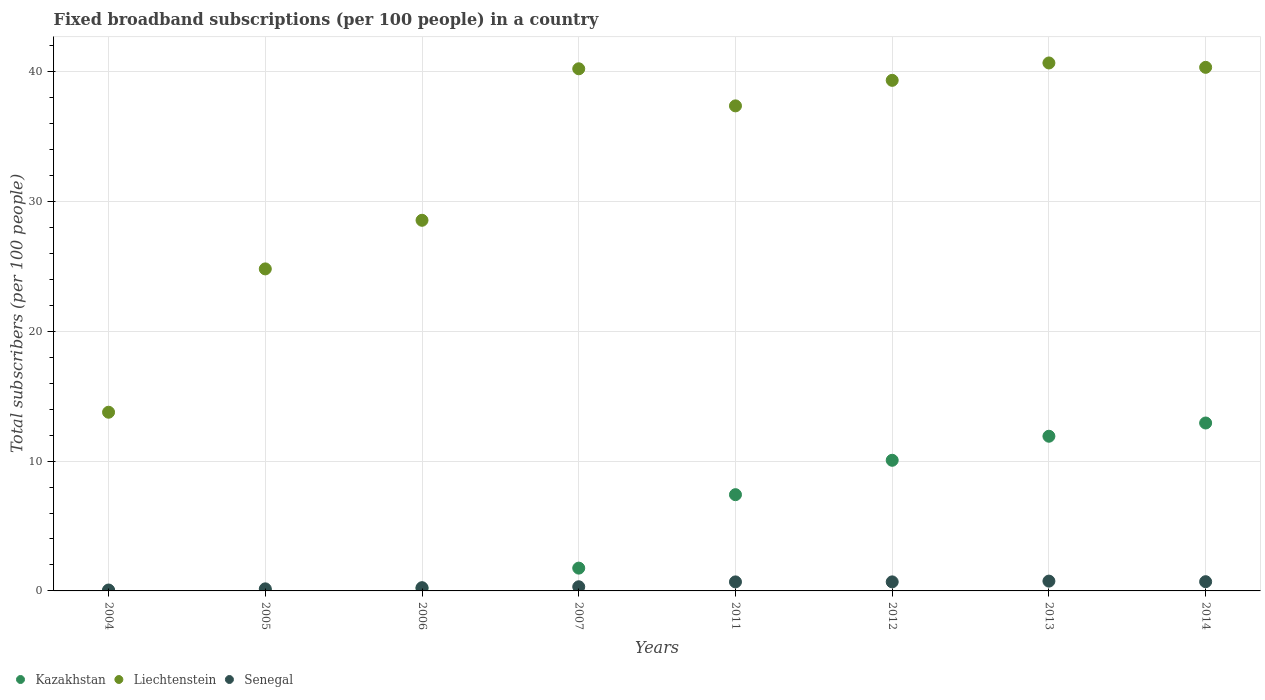How many different coloured dotlines are there?
Provide a short and direct response. 3. What is the number of broadband subscriptions in Senegal in 2013?
Provide a succinct answer. 0.76. Across all years, what is the maximum number of broadband subscriptions in Kazakhstan?
Give a very brief answer. 12.93. Across all years, what is the minimum number of broadband subscriptions in Kazakhstan?
Keep it short and to the point. 0.01. What is the total number of broadband subscriptions in Kazakhstan in the graph?
Offer a very short reply. 44.31. What is the difference between the number of broadband subscriptions in Kazakhstan in 2007 and that in 2012?
Your response must be concise. -8.31. What is the difference between the number of broadband subscriptions in Liechtenstein in 2013 and the number of broadband subscriptions in Kazakhstan in 2005?
Your answer should be compact. 40.65. What is the average number of broadband subscriptions in Liechtenstein per year?
Keep it short and to the point. 33.13. In the year 2004, what is the difference between the number of broadband subscriptions in Senegal and number of broadband subscriptions in Liechtenstein?
Your response must be concise. -13.69. What is the ratio of the number of broadband subscriptions in Liechtenstein in 2005 to that in 2011?
Offer a very short reply. 0.66. Is the number of broadband subscriptions in Senegal in 2007 less than that in 2012?
Offer a very short reply. Yes. What is the difference between the highest and the second highest number of broadband subscriptions in Kazakhstan?
Keep it short and to the point. 1.02. What is the difference between the highest and the lowest number of broadband subscriptions in Kazakhstan?
Offer a very short reply. 12.92. Is it the case that in every year, the sum of the number of broadband subscriptions in Liechtenstein and number of broadband subscriptions in Kazakhstan  is greater than the number of broadband subscriptions in Senegal?
Give a very brief answer. Yes. Is the number of broadband subscriptions in Kazakhstan strictly greater than the number of broadband subscriptions in Senegal over the years?
Offer a terse response. No. Is the number of broadband subscriptions in Senegal strictly less than the number of broadband subscriptions in Liechtenstein over the years?
Offer a very short reply. Yes. How many years are there in the graph?
Provide a succinct answer. 8. What is the difference between two consecutive major ticks on the Y-axis?
Offer a very short reply. 10. Does the graph contain grids?
Provide a succinct answer. Yes. What is the title of the graph?
Keep it short and to the point. Fixed broadband subscriptions (per 100 people) in a country. What is the label or title of the Y-axis?
Make the answer very short. Total subscribers (per 100 people). What is the Total subscribers (per 100 people) in Kazakhstan in 2004?
Make the answer very short. 0.01. What is the Total subscribers (per 100 people) in Liechtenstein in 2004?
Give a very brief answer. 13.76. What is the Total subscribers (per 100 people) in Senegal in 2004?
Your answer should be compact. 0.07. What is the Total subscribers (per 100 people) in Kazakhstan in 2005?
Offer a terse response. 0.02. What is the Total subscribers (per 100 people) of Liechtenstein in 2005?
Offer a very short reply. 24.8. What is the Total subscribers (per 100 people) of Senegal in 2005?
Offer a very short reply. 0.16. What is the Total subscribers (per 100 people) in Kazakhstan in 2006?
Your response must be concise. 0.2. What is the Total subscribers (per 100 people) in Liechtenstein in 2006?
Offer a very short reply. 28.55. What is the Total subscribers (per 100 people) in Senegal in 2006?
Make the answer very short. 0.25. What is the Total subscribers (per 100 people) of Kazakhstan in 2007?
Your answer should be compact. 1.76. What is the Total subscribers (per 100 people) in Liechtenstein in 2007?
Offer a terse response. 40.22. What is the Total subscribers (per 100 people) in Senegal in 2007?
Offer a terse response. 0.32. What is the Total subscribers (per 100 people) in Kazakhstan in 2011?
Your answer should be compact. 7.41. What is the Total subscribers (per 100 people) of Liechtenstein in 2011?
Give a very brief answer. 37.36. What is the Total subscribers (per 100 people) in Senegal in 2011?
Give a very brief answer. 0.7. What is the Total subscribers (per 100 people) of Kazakhstan in 2012?
Ensure brevity in your answer.  10.06. What is the Total subscribers (per 100 people) in Liechtenstein in 2012?
Your answer should be compact. 39.33. What is the Total subscribers (per 100 people) in Senegal in 2012?
Offer a very short reply. 0.7. What is the Total subscribers (per 100 people) of Kazakhstan in 2013?
Your answer should be compact. 11.91. What is the Total subscribers (per 100 people) in Liechtenstein in 2013?
Make the answer very short. 40.67. What is the Total subscribers (per 100 people) of Senegal in 2013?
Offer a very short reply. 0.76. What is the Total subscribers (per 100 people) in Kazakhstan in 2014?
Make the answer very short. 12.93. What is the Total subscribers (per 100 people) of Liechtenstein in 2014?
Offer a very short reply. 40.33. What is the Total subscribers (per 100 people) in Senegal in 2014?
Your response must be concise. 0.71. Across all years, what is the maximum Total subscribers (per 100 people) in Kazakhstan?
Your answer should be very brief. 12.93. Across all years, what is the maximum Total subscribers (per 100 people) of Liechtenstein?
Offer a terse response. 40.67. Across all years, what is the maximum Total subscribers (per 100 people) in Senegal?
Offer a very short reply. 0.76. Across all years, what is the minimum Total subscribers (per 100 people) of Kazakhstan?
Offer a very short reply. 0.01. Across all years, what is the minimum Total subscribers (per 100 people) in Liechtenstein?
Make the answer very short. 13.76. Across all years, what is the minimum Total subscribers (per 100 people) in Senegal?
Your answer should be very brief. 0.07. What is the total Total subscribers (per 100 people) of Kazakhstan in the graph?
Offer a terse response. 44.31. What is the total Total subscribers (per 100 people) in Liechtenstein in the graph?
Make the answer very short. 265.02. What is the total Total subscribers (per 100 people) of Senegal in the graph?
Make the answer very short. 3.66. What is the difference between the Total subscribers (per 100 people) of Kazakhstan in 2004 and that in 2005?
Make the answer very short. -0.01. What is the difference between the Total subscribers (per 100 people) of Liechtenstein in 2004 and that in 2005?
Give a very brief answer. -11.04. What is the difference between the Total subscribers (per 100 people) in Senegal in 2004 and that in 2005?
Provide a succinct answer. -0.09. What is the difference between the Total subscribers (per 100 people) in Kazakhstan in 2004 and that in 2006?
Give a very brief answer. -0.19. What is the difference between the Total subscribers (per 100 people) of Liechtenstein in 2004 and that in 2006?
Your answer should be very brief. -14.78. What is the difference between the Total subscribers (per 100 people) in Senegal in 2004 and that in 2006?
Your answer should be very brief. -0.18. What is the difference between the Total subscribers (per 100 people) in Kazakhstan in 2004 and that in 2007?
Offer a terse response. -1.74. What is the difference between the Total subscribers (per 100 people) in Liechtenstein in 2004 and that in 2007?
Provide a short and direct response. -26.45. What is the difference between the Total subscribers (per 100 people) in Senegal in 2004 and that in 2007?
Provide a short and direct response. -0.25. What is the difference between the Total subscribers (per 100 people) in Kazakhstan in 2004 and that in 2011?
Your answer should be compact. -7.4. What is the difference between the Total subscribers (per 100 people) in Liechtenstein in 2004 and that in 2011?
Ensure brevity in your answer.  -23.6. What is the difference between the Total subscribers (per 100 people) of Senegal in 2004 and that in 2011?
Your answer should be compact. -0.63. What is the difference between the Total subscribers (per 100 people) of Kazakhstan in 2004 and that in 2012?
Provide a short and direct response. -10.05. What is the difference between the Total subscribers (per 100 people) in Liechtenstein in 2004 and that in 2012?
Give a very brief answer. -25.56. What is the difference between the Total subscribers (per 100 people) of Senegal in 2004 and that in 2012?
Ensure brevity in your answer.  -0.63. What is the difference between the Total subscribers (per 100 people) of Kazakhstan in 2004 and that in 2013?
Offer a very short reply. -11.9. What is the difference between the Total subscribers (per 100 people) of Liechtenstein in 2004 and that in 2013?
Your response must be concise. -26.9. What is the difference between the Total subscribers (per 100 people) in Senegal in 2004 and that in 2013?
Offer a very short reply. -0.69. What is the difference between the Total subscribers (per 100 people) in Kazakhstan in 2004 and that in 2014?
Offer a terse response. -12.92. What is the difference between the Total subscribers (per 100 people) of Liechtenstein in 2004 and that in 2014?
Ensure brevity in your answer.  -26.57. What is the difference between the Total subscribers (per 100 people) of Senegal in 2004 and that in 2014?
Your answer should be very brief. -0.64. What is the difference between the Total subscribers (per 100 people) of Kazakhstan in 2005 and that in 2006?
Give a very brief answer. -0.18. What is the difference between the Total subscribers (per 100 people) of Liechtenstein in 2005 and that in 2006?
Keep it short and to the point. -3.74. What is the difference between the Total subscribers (per 100 people) in Senegal in 2005 and that in 2006?
Make the answer very short. -0.09. What is the difference between the Total subscribers (per 100 people) in Kazakhstan in 2005 and that in 2007?
Ensure brevity in your answer.  -1.74. What is the difference between the Total subscribers (per 100 people) in Liechtenstein in 2005 and that in 2007?
Your answer should be very brief. -15.41. What is the difference between the Total subscribers (per 100 people) in Senegal in 2005 and that in 2007?
Your response must be concise. -0.16. What is the difference between the Total subscribers (per 100 people) in Kazakhstan in 2005 and that in 2011?
Keep it short and to the point. -7.39. What is the difference between the Total subscribers (per 100 people) in Liechtenstein in 2005 and that in 2011?
Make the answer very short. -12.56. What is the difference between the Total subscribers (per 100 people) in Senegal in 2005 and that in 2011?
Provide a short and direct response. -0.54. What is the difference between the Total subscribers (per 100 people) of Kazakhstan in 2005 and that in 2012?
Offer a very short reply. -10.04. What is the difference between the Total subscribers (per 100 people) of Liechtenstein in 2005 and that in 2012?
Provide a succinct answer. -14.52. What is the difference between the Total subscribers (per 100 people) in Senegal in 2005 and that in 2012?
Your response must be concise. -0.54. What is the difference between the Total subscribers (per 100 people) of Kazakhstan in 2005 and that in 2013?
Offer a very short reply. -11.89. What is the difference between the Total subscribers (per 100 people) in Liechtenstein in 2005 and that in 2013?
Your answer should be very brief. -15.86. What is the difference between the Total subscribers (per 100 people) of Senegal in 2005 and that in 2013?
Keep it short and to the point. -0.6. What is the difference between the Total subscribers (per 100 people) in Kazakhstan in 2005 and that in 2014?
Offer a very short reply. -12.91. What is the difference between the Total subscribers (per 100 people) of Liechtenstein in 2005 and that in 2014?
Your response must be concise. -15.52. What is the difference between the Total subscribers (per 100 people) in Senegal in 2005 and that in 2014?
Your answer should be very brief. -0.55. What is the difference between the Total subscribers (per 100 people) of Kazakhstan in 2006 and that in 2007?
Provide a short and direct response. -1.56. What is the difference between the Total subscribers (per 100 people) in Liechtenstein in 2006 and that in 2007?
Ensure brevity in your answer.  -11.67. What is the difference between the Total subscribers (per 100 people) of Senegal in 2006 and that in 2007?
Give a very brief answer. -0.07. What is the difference between the Total subscribers (per 100 people) in Kazakhstan in 2006 and that in 2011?
Provide a short and direct response. -7.21. What is the difference between the Total subscribers (per 100 people) of Liechtenstein in 2006 and that in 2011?
Your response must be concise. -8.81. What is the difference between the Total subscribers (per 100 people) of Senegal in 2006 and that in 2011?
Ensure brevity in your answer.  -0.45. What is the difference between the Total subscribers (per 100 people) in Kazakhstan in 2006 and that in 2012?
Your response must be concise. -9.86. What is the difference between the Total subscribers (per 100 people) of Liechtenstein in 2006 and that in 2012?
Provide a short and direct response. -10.78. What is the difference between the Total subscribers (per 100 people) in Senegal in 2006 and that in 2012?
Provide a short and direct response. -0.45. What is the difference between the Total subscribers (per 100 people) in Kazakhstan in 2006 and that in 2013?
Provide a succinct answer. -11.71. What is the difference between the Total subscribers (per 100 people) in Liechtenstein in 2006 and that in 2013?
Provide a short and direct response. -12.12. What is the difference between the Total subscribers (per 100 people) of Senegal in 2006 and that in 2013?
Offer a terse response. -0.51. What is the difference between the Total subscribers (per 100 people) of Kazakhstan in 2006 and that in 2014?
Give a very brief answer. -12.73. What is the difference between the Total subscribers (per 100 people) of Liechtenstein in 2006 and that in 2014?
Offer a very short reply. -11.78. What is the difference between the Total subscribers (per 100 people) of Senegal in 2006 and that in 2014?
Offer a terse response. -0.46. What is the difference between the Total subscribers (per 100 people) of Kazakhstan in 2007 and that in 2011?
Provide a short and direct response. -5.66. What is the difference between the Total subscribers (per 100 people) of Liechtenstein in 2007 and that in 2011?
Offer a very short reply. 2.86. What is the difference between the Total subscribers (per 100 people) in Senegal in 2007 and that in 2011?
Offer a very short reply. -0.38. What is the difference between the Total subscribers (per 100 people) in Kazakhstan in 2007 and that in 2012?
Offer a terse response. -8.31. What is the difference between the Total subscribers (per 100 people) in Liechtenstein in 2007 and that in 2012?
Keep it short and to the point. 0.89. What is the difference between the Total subscribers (per 100 people) of Senegal in 2007 and that in 2012?
Keep it short and to the point. -0.38. What is the difference between the Total subscribers (per 100 people) of Kazakhstan in 2007 and that in 2013?
Offer a very short reply. -10.16. What is the difference between the Total subscribers (per 100 people) in Liechtenstein in 2007 and that in 2013?
Give a very brief answer. -0.45. What is the difference between the Total subscribers (per 100 people) in Senegal in 2007 and that in 2013?
Provide a short and direct response. -0.43. What is the difference between the Total subscribers (per 100 people) of Kazakhstan in 2007 and that in 2014?
Offer a terse response. -11.18. What is the difference between the Total subscribers (per 100 people) of Liechtenstein in 2007 and that in 2014?
Give a very brief answer. -0.11. What is the difference between the Total subscribers (per 100 people) in Senegal in 2007 and that in 2014?
Offer a terse response. -0.39. What is the difference between the Total subscribers (per 100 people) in Kazakhstan in 2011 and that in 2012?
Ensure brevity in your answer.  -2.65. What is the difference between the Total subscribers (per 100 people) of Liechtenstein in 2011 and that in 2012?
Offer a very short reply. -1.97. What is the difference between the Total subscribers (per 100 people) in Senegal in 2011 and that in 2012?
Offer a very short reply. -0. What is the difference between the Total subscribers (per 100 people) of Kazakhstan in 2011 and that in 2013?
Provide a succinct answer. -4.5. What is the difference between the Total subscribers (per 100 people) in Liechtenstein in 2011 and that in 2013?
Provide a succinct answer. -3.31. What is the difference between the Total subscribers (per 100 people) in Senegal in 2011 and that in 2013?
Offer a terse response. -0.06. What is the difference between the Total subscribers (per 100 people) of Kazakhstan in 2011 and that in 2014?
Provide a succinct answer. -5.52. What is the difference between the Total subscribers (per 100 people) in Liechtenstein in 2011 and that in 2014?
Your answer should be very brief. -2.97. What is the difference between the Total subscribers (per 100 people) of Senegal in 2011 and that in 2014?
Your answer should be very brief. -0.01. What is the difference between the Total subscribers (per 100 people) of Kazakhstan in 2012 and that in 2013?
Make the answer very short. -1.85. What is the difference between the Total subscribers (per 100 people) of Liechtenstein in 2012 and that in 2013?
Provide a short and direct response. -1.34. What is the difference between the Total subscribers (per 100 people) of Senegal in 2012 and that in 2013?
Your response must be concise. -0.06. What is the difference between the Total subscribers (per 100 people) in Kazakhstan in 2012 and that in 2014?
Offer a terse response. -2.87. What is the difference between the Total subscribers (per 100 people) in Liechtenstein in 2012 and that in 2014?
Offer a terse response. -1. What is the difference between the Total subscribers (per 100 people) in Senegal in 2012 and that in 2014?
Your answer should be compact. -0.01. What is the difference between the Total subscribers (per 100 people) of Kazakhstan in 2013 and that in 2014?
Your response must be concise. -1.02. What is the difference between the Total subscribers (per 100 people) of Liechtenstein in 2013 and that in 2014?
Provide a short and direct response. 0.34. What is the difference between the Total subscribers (per 100 people) in Senegal in 2013 and that in 2014?
Give a very brief answer. 0.04. What is the difference between the Total subscribers (per 100 people) of Kazakhstan in 2004 and the Total subscribers (per 100 people) of Liechtenstein in 2005?
Your response must be concise. -24.79. What is the difference between the Total subscribers (per 100 people) of Kazakhstan in 2004 and the Total subscribers (per 100 people) of Senegal in 2005?
Keep it short and to the point. -0.15. What is the difference between the Total subscribers (per 100 people) of Liechtenstein in 2004 and the Total subscribers (per 100 people) of Senegal in 2005?
Offer a very short reply. 13.6. What is the difference between the Total subscribers (per 100 people) of Kazakhstan in 2004 and the Total subscribers (per 100 people) of Liechtenstein in 2006?
Your answer should be compact. -28.54. What is the difference between the Total subscribers (per 100 people) of Kazakhstan in 2004 and the Total subscribers (per 100 people) of Senegal in 2006?
Provide a short and direct response. -0.24. What is the difference between the Total subscribers (per 100 people) in Liechtenstein in 2004 and the Total subscribers (per 100 people) in Senegal in 2006?
Your answer should be very brief. 13.51. What is the difference between the Total subscribers (per 100 people) of Kazakhstan in 2004 and the Total subscribers (per 100 people) of Liechtenstein in 2007?
Your answer should be compact. -40.2. What is the difference between the Total subscribers (per 100 people) in Kazakhstan in 2004 and the Total subscribers (per 100 people) in Senegal in 2007?
Offer a very short reply. -0.31. What is the difference between the Total subscribers (per 100 people) of Liechtenstein in 2004 and the Total subscribers (per 100 people) of Senegal in 2007?
Keep it short and to the point. 13.44. What is the difference between the Total subscribers (per 100 people) of Kazakhstan in 2004 and the Total subscribers (per 100 people) of Liechtenstein in 2011?
Offer a very short reply. -37.35. What is the difference between the Total subscribers (per 100 people) of Kazakhstan in 2004 and the Total subscribers (per 100 people) of Senegal in 2011?
Make the answer very short. -0.68. What is the difference between the Total subscribers (per 100 people) in Liechtenstein in 2004 and the Total subscribers (per 100 people) in Senegal in 2011?
Provide a succinct answer. 13.07. What is the difference between the Total subscribers (per 100 people) of Kazakhstan in 2004 and the Total subscribers (per 100 people) of Liechtenstein in 2012?
Give a very brief answer. -39.31. What is the difference between the Total subscribers (per 100 people) in Kazakhstan in 2004 and the Total subscribers (per 100 people) in Senegal in 2012?
Give a very brief answer. -0.68. What is the difference between the Total subscribers (per 100 people) in Liechtenstein in 2004 and the Total subscribers (per 100 people) in Senegal in 2012?
Give a very brief answer. 13.07. What is the difference between the Total subscribers (per 100 people) of Kazakhstan in 2004 and the Total subscribers (per 100 people) of Liechtenstein in 2013?
Provide a short and direct response. -40.65. What is the difference between the Total subscribers (per 100 people) of Kazakhstan in 2004 and the Total subscribers (per 100 people) of Senegal in 2013?
Offer a very short reply. -0.74. What is the difference between the Total subscribers (per 100 people) in Liechtenstein in 2004 and the Total subscribers (per 100 people) in Senegal in 2013?
Keep it short and to the point. 13.01. What is the difference between the Total subscribers (per 100 people) of Kazakhstan in 2004 and the Total subscribers (per 100 people) of Liechtenstein in 2014?
Give a very brief answer. -40.32. What is the difference between the Total subscribers (per 100 people) of Kazakhstan in 2004 and the Total subscribers (per 100 people) of Senegal in 2014?
Offer a very short reply. -0.7. What is the difference between the Total subscribers (per 100 people) of Liechtenstein in 2004 and the Total subscribers (per 100 people) of Senegal in 2014?
Ensure brevity in your answer.  13.05. What is the difference between the Total subscribers (per 100 people) of Kazakhstan in 2005 and the Total subscribers (per 100 people) of Liechtenstein in 2006?
Offer a terse response. -28.53. What is the difference between the Total subscribers (per 100 people) of Kazakhstan in 2005 and the Total subscribers (per 100 people) of Senegal in 2006?
Ensure brevity in your answer.  -0.23. What is the difference between the Total subscribers (per 100 people) in Liechtenstein in 2005 and the Total subscribers (per 100 people) in Senegal in 2006?
Offer a terse response. 24.55. What is the difference between the Total subscribers (per 100 people) of Kazakhstan in 2005 and the Total subscribers (per 100 people) of Liechtenstein in 2007?
Your answer should be very brief. -40.2. What is the difference between the Total subscribers (per 100 people) of Kazakhstan in 2005 and the Total subscribers (per 100 people) of Senegal in 2007?
Keep it short and to the point. -0.3. What is the difference between the Total subscribers (per 100 people) in Liechtenstein in 2005 and the Total subscribers (per 100 people) in Senegal in 2007?
Make the answer very short. 24.48. What is the difference between the Total subscribers (per 100 people) of Kazakhstan in 2005 and the Total subscribers (per 100 people) of Liechtenstein in 2011?
Ensure brevity in your answer.  -37.34. What is the difference between the Total subscribers (per 100 people) in Kazakhstan in 2005 and the Total subscribers (per 100 people) in Senegal in 2011?
Your answer should be very brief. -0.68. What is the difference between the Total subscribers (per 100 people) of Liechtenstein in 2005 and the Total subscribers (per 100 people) of Senegal in 2011?
Ensure brevity in your answer.  24.11. What is the difference between the Total subscribers (per 100 people) in Kazakhstan in 2005 and the Total subscribers (per 100 people) in Liechtenstein in 2012?
Offer a terse response. -39.31. What is the difference between the Total subscribers (per 100 people) of Kazakhstan in 2005 and the Total subscribers (per 100 people) of Senegal in 2012?
Keep it short and to the point. -0.68. What is the difference between the Total subscribers (per 100 people) in Liechtenstein in 2005 and the Total subscribers (per 100 people) in Senegal in 2012?
Ensure brevity in your answer.  24.11. What is the difference between the Total subscribers (per 100 people) of Kazakhstan in 2005 and the Total subscribers (per 100 people) of Liechtenstein in 2013?
Provide a short and direct response. -40.65. What is the difference between the Total subscribers (per 100 people) of Kazakhstan in 2005 and the Total subscribers (per 100 people) of Senegal in 2013?
Your answer should be very brief. -0.74. What is the difference between the Total subscribers (per 100 people) in Liechtenstein in 2005 and the Total subscribers (per 100 people) in Senegal in 2013?
Provide a succinct answer. 24.05. What is the difference between the Total subscribers (per 100 people) in Kazakhstan in 2005 and the Total subscribers (per 100 people) in Liechtenstein in 2014?
Provide a succinct answer. -40.31. What is the difference between the Total subscribers (per 100 people) of Kazakhstan in 2005 and the Total subscribers (per 100 people) of Senegal in 2014?
Give a very brief answer. -0.69. What is the difference between the Total subscribers (per 100 people) of Liechtenstein in 2005 and the Total subscribers (per 100 people) of Senegal in 2014?
Your answer should be very brief. 24.09. What is the difference between the Total subscribers (per 100 people) in Kazakhstan in 2006 and the Total subscribers (per 100 people) in Liechtenstein in 2007?
Give a very brief answer. -40.02. What is the difference between the Total subscribers (per 100 people) of Kazakhstan in 2006 and the Total subscribers (per 100 people) of Senegal in 2007?
Provide a short and direct response. -0.12. What is the difference between the Total subscribers (per 100 people) of Liechtenstein in 2006 and the Total subscribers (per 100 people) of Senegal in 2007?
Provide a succinct answer. 28.23. What is the difference between the Total subscribers (per 100 people) in Kazakhstan in 2006 and the Total subscribers (per 100 people) in Liechtenstein in 2011?
Ensure brevity in your answer.  -37.16. What is the difference between the Total subscribers (per 100 people) in Kazakhstan in 2006 and the Total subscribers (per 100 people) in Senegal in 2011?
Your answer should be very brief. -0.5. What is the difference between the Total subscribers (per 100 people) of Liechtenstein in 2006 and the Total subscribers (per 100 people) of Senegal in 2011?
Provide a succinct answer. 27.85. What is the difference between the Total subscribers (per 100 people) of Kazakhstan in 2006 and the Total subscribers (per 100 people) of Liechtenstein in 2012?
Your response must be concise. -39.13. What is the difference between the Total subscribers (per 100 people) in Kazakhstan in 2006 and the Total subscribers (per 100 people) in Senegal in 2012?
Offer a terse response. -0.5. What is the difference between the Total subscribers (per 100 people) of Liechtenstein in 2006 and the Total subscribers (per 100 people) of Senegal in 2012?
Provide a succinct answer. 27.85. What is the difference between the Total subscribers (per 100 people) in Kazakhstan in 2006 and the Total subscribers (per 100 people) in Liechtenstein in 2013?
Your answer should be very brief. -40.47. What is the difference between the Total subscribers (per 100 people) in Kazakhstan in 2006 and the Total subscribers (per 100 people) in Senegal in 2013?
Your answer should be very brief. -0.55. What is the difference between the Total subscribers (per 100 people) of Liechtenstein in 2006 and the Total subscribers (per 100 people) of Senegal in 2013?
Provide a succinct answer. 27.79. What is the difference between the Total subscribers (per 100 people) in Kazakhstan in 2006 and the Total subscribers (per 100 people) in Liechtenstein in 2014?
Keep it short and to the point. -40.13. What is the difference between the Total subscribers (per 100 people) of Kazakhstan in 2006 and the Total subscribers (per 100 people) of Senegal in 2014?
Ensure brevity in your answer.  -0.51. What is the difference between the Total subscribers (per 100 people) in Liechtenstein in 2006 and the Total subscribers (per 100 people) in Senegal in 2014?
Provide a succinct answer. 27.84. What is the difference between the Total subscribers (per 100 people) in Kazakhstan in 2007 and the Total subscribers (per 100 people) in Liechtenstein in 2011?
Provide a short and direct response. -35.61. What is the difference between the Total subscribers (per 100 people) in Kazakhstan in 2007 and the Total subscribers (per 100 people) in Senegal in 2011?
Your answer should be compact. 1.06. What is the difference between the Total subscribers (per 100 people) of Liechtenstein in 2007 and the Total subscribers (per 100 people) of Senegal in 2011?
Offer a very short reply. 39.52. What is the difference between the Total subscribers (per 100 people) of Kazakhstan in 2007 and the Total subscribers (per 100 people) of Liechtenstein in 2012?
Your answer should be compact. -37.57. What is the difference between the Total subscribers (per 100 people) of Kazakhstan in 2007 and the Total subscribers (per 100 people) of Senegal in 2012?
Ensure brevity in your answer.  1.06. What is the difference between the Total subscribers (per 100 people) of Liechtenstein in 2007 and the Total subscribers (per 100 people) of Senegal in 2012?
Offer a very short reply. 39.52. What is the difference between the Total subscribers (per 100 people) in Kazakhstan in 2007 and the Total subscribers (per 100 people) in Liechtenstein in 2013?
Offer a very short reply. -38.91. What is the difference between the Total subscribers (per 100 people) of Kazakhstan in 2007 and the Total subscribers (per 100 people) of Senegal in 2013?
Provide a succinct answer. 1. What is the difference between the Total subscribers (per 100 people) in Liechtenstein in 2007 and the Total subscribers (per 100 people) in Senegal in 2013?
Offer a terse response. 39.46. What is the difference between the Total subscribers (per 100 people) in Kazakhstan in 2007 and the Total subscribers (per 100 people) in Liechtenstein in 2014?
Offer a very short reply. -38.57. What is the difference between the Total subscribers (per 100 people) of Kazakhstan in 2007 and the Total subscribers (per 100 people) of Senegal in 2014?
Ensure brevity in your answer.  1.05. What is the difference between the Total subscribers (per 100 people) of Liechtenstein in 2007 and the Total subscribers (per 100 people) of Senegal in 2014?
Give a very brief answer. 39.51. What is the difference between the Total subscribers (per 100 people) in Kazakhstan in 2011 and the Total subscribers (per 100 people) in Liechtenstein in 2012?
Provide a short and direct response. -31.91. What is the difference between the Total subscribers (per 100 people) in Kazakhstan in 2011 and the Total subscribers (per 100 people) in Senegal in 2012?
Ensure brevity in your answer.  6.72. What is the difference between the Total subscribers (per 100 people) of Liechtenstein in 2011 and the Total subscribers (per 100 people) of Senegal in 2012?
Provide a succinct answer. 36.66. What is the difference between the Total subscribers (per 100 people) in Kazakhstan in 2011 and the Total subscribers (per 100 people) in Liechtenstein in 2013?
Your answer should be very brief. -33.25. What is the difference between the Total subscribers (per 100 people) of Kazakhstan in 2011 and the Total subscribers (per 100 people) of Senegal in 2013?
Provide a short and direct response. 6.66. What is the difference between the Total subscribers (per 100 people) of Liechtenstein in 2011 and the Total subscribers (per 100 people) of Senegal in 2013?
Make the answer very short. 36.61. What is the difference between the Total subscribers (per 100 people) in Kazakhstan in 2011 and the Total subscribers (per 100 people) in Liechtenstein in 2014?
Offer a terse response. -32.92. What is the difference between the Total subscribers (per 100 people) in Kazakhstan in 2011 and the Total subscribers (per 100 people) in Senegal in 2014?
Your answer should be compact. 6.7. What is the difference between the Total subscribers (per 100 people) in Liechtenstein in 2011 and the Total subscribers (per 100 people) in Senegal in 2014?
Give a very brief answer. 36.65. What is the difference between the Total subscribers (per 100 people) of Kazakhstan in 2012 and the Total subscribers (per 100 people) of Liechtenstein in 2013?
Offer a very short reply. -30.6. What is the difference between the Total subscribers (per 100 people) in Kazakhstan in 2012 and the Total subscribers (per 100 people) in Senegal in 2013?
Your response must be concise. 9.31. What is the difference between the Total subscribers (per 100 people) of Liechtenstein in 2012 and the Total subscribers (per 100 people) of Senegal in 2013?
Offer a very short reply. 38.57. What is the difference between the Total subscribers (per 100 people) in Kazakhstan in 2012 and the Total subscribers (per 100 people) in Liechtenstein in 2014?
Give a very brief answer. -30.27. What is the difference between the Total subscribers (per 100 people) in Kazakhstan in 2012 and the Total subscribers (per 100 people) in Senegal in 2014?
Provide a short and direct response. 9.35. What is the difference between the Total subscribers (per 100 people) in Liechtenstein in 2012 and the Total subscribers (per 100 people) in Senegal in 2014?
Give a very brief answer. 38.62. What is the difference between the Total subscribers (per 100 people) of Kazakhstan in 2013 and the Total subscribers (per 100 people) of Liechtenstein in 2014?
Make the answer very short. -28.41. What is the difference between the Total subscribers (per 100 people) in Kazakhstan in 2013 and the Total subscribers (per 100 people) in Senegal in 2014?
Offer a very short reply. 11.2. What is the difference between the Total subscribers (per 100 people) in Liechtenstein in 2013 and the Total subscribers (per 100 people) in Senegal in 2014?
Offer a terse response. 39.96. What is the average Total subscribers (per 100 people) of Kazakhstan per year?
Give a very brief answer. 5.54. What is the average Total subscribers (per 100 people) of Liechtenstein per year?
Your response must be concise. 33.13. What is the average Total subscribers (per 100 people) of Senegal per year?
Keep it short and to the point. 0.46. In the year 2004, what is the difference between the Total subscribers (per 100 people) of Kazakhstan and Total subscribers (per 100 people) of Liechtenstein?
Ensure brevity in your answer.  -13.75. In the year 2004, what is the difference between the Total subscribers (per 100 people) in Kazakhstan and Total subscribers (per 100 people) in Senegal?
Give a very brief answer. -0.06. In the year 2004, what is the difference between the Total subscribers (per 100 people) in Liechtenstein and Total subscribers (per 100 people) in Senegal?
Offer a terse response. 13.69. In the year 2005, what is the difference between the Total subscribers (per 100 people) of Kazakhstan and Total subscribers (per 100 people) of Liechtenstein?
Your answer should be compact. -24.78. In the year 2005, what is the difference between the Total subscribers (per 100 people) in Kazakhstan and Total subscribers (per 100 people) in Senegal?
Offer a very short reply. -0.14. In the year 2005, what is the difference between the Total subscribers (per 100 people) in Liechtenstein and Total subscribers (per 100 people) in Senegal?
Keep it short and to the point. 24.64. In the year 2006, what is the difference between the Total subscribers (per 100 people) of Kazakhstan and Total subscribers (per 100 people) of Liechtenstein?
Make the answer very short. -28.35. In the year 2006, what is the difference between the Total subscribers (per 100 people) in Kazakhstan and Total subscribers (per 100 people) in Senegal?
Give a very brief answer. -0.05. In the year 2006, what is the difference between the Total subscribers (per 100 people) in Liechtenstein and Total subscribers (per 100 people) in Senegal?
Your response must be concise. 28.3. In the year 2007, what is the difference between the Total subscribers (per 100 people) in Kazakhstan and Total subscribers (per 100 people) in Liechtenstein?
Your answer should be compact. -38.46. In the year 2007, what is the difference between the Total subscribers (per 100 people) of Kazakhstan and Total subscribers (per 100 people) of Senegal?
Give a very brief answer. 1.44. In the year 2007, what is the difference between the Total subscribers (per 100 people) in Liechtenstein and Total subscribers (per 100 people) in Senegal?
Your answer should be very brief. 39.9. In the year 2011, what is the difference between the Total subscribers (per 100 people) in Kazakhstan and Total subscribers (per 100 people) in Liechtenstein?
Provide a succinct answer. -29.95. In the year 2011, what is the difference between the Total subscribers (per 100 people) in Kazakhstan and Total subscribers (per 100 people) in Senegal?
Offer a very short reply. 6.72. In the year 2011, what is the difference between the Total subscribers (per 100 people) in Liechtenstein and Total subscribers (per 100 people) in Senegal?
Ensure brevity in your answer.  36.67. In the year 2012, what is the difference between the Total subscribers (per 100 people) in Kazakhstan and Total subscribers (per 100 people) in Liechtenstein?
Provide a succinct answer. -29.27. In the year 2012, what is the difference between the Total subscribers (per 100 people) of Kazakhstan and Total subscribers (per 100 people) of Senegal?
Keep it short and to the point. 9.37. In the year 2012, what is the difference between the Total subscribers (per 100 people) of Liechtenstein and Total subscribers (per 100 people) of Senegal?
Provide a succinct answer. 38.63. In the year 2013, what is the difference between the Total subscribers (per 100 people) in Kazakhstan and Total subscribers (per 100 people) in Liechtenstein?
Give a very brief answer. -28.75. In the year 2013, what is the difference between the Total subscribers (per 100 people) of Kazakhstan and Total subscribers (per 100 people) of Senegal?
Offer a terse response. 11.16. In the year 2013, what is the difference between the Total subscribers (per 100 people) of Liechtenstein and Total subscribers (per 100 people) of Senegal?
Provide a short and direct response. 39.91. In the year 2014, what is the difference between the Total subscribers (per 100 people) in Kazakhstan and Total subscribers (per 100 people) in Liechtenstein?
Ensure brevity in your answer.  -27.39. In the year 2014, what is the difference between the Total subscribers (per 100 people) in Kazakhstan and Total subscribers (per 100 people) in Senegal?
Make the answer very short. 12.22. In the year 2014, what is the difference between the Total subscribers (per 100 people) in Liechtenstein and Total subscribers (per 100 people) in Senegal?
Give a very brief answer. 39.62. What is the ratio of the Total subscribers (per 100 people) of Kazakhstan in 2004 to that in 2005?
Make the answer very short. 0.67. What is the ratio of the Total subscribers (per 100 people) of Liechtenstein in 2004 to that in 2005?
Keep it short and to the point. 0.55. What is the ratio of the Total subscribers (per 100 people) in Senegal in 2004 to that in 2005?
Give a very brief answer. 0.44. What is the ratio of the Total subscribers (per 100 people) in Kazakhstan in 2004 to that in 2006?
Your response must be concise. 0.07. What is the ratio of the Total subscribers (per 100 people) in Liechtenstein in 2004 to that in 2006?
Your answer should be very brief. 0.48. What is the ratio of the Total subscribers (per 100 people) in Senegal in 2004 to that in 2006?
Ensure brevity in your answer.  0.28. What is the ratio of the Total subscribers (per 100 people) in Kazakhstan in 2004 to that in 2007?
Keep it short and to the point. 0.01. What is the ratio of the Total subscribers (per 100 people) in Liechtenstein in 2004 to that in 2007?
Give a very brief answer. 0.34. What is the ratio of the Total subscribers (per 100 people) in Senegal in 2004 to that in 2007?
Your answer should be very brief. 0.22. What is the ratio of the Total subscribers (per 100 people) of Kazakhstan in 2004 to that in 2011?
Your answer should be very brief. 0. What is the ratio of the Total subscribers (per 100 people) in Liechtenstein in 2004 to that in 2011?
Ensure brevity in your answer.  0.37. What is the ratio of the Total subscribers (per 100 people) of Senegal in 2004 to that in 2011?
Provide a succinct answer. 0.1. What is the ratio of the Total subscribers (per 100 people) in Kazakhstan in 2004 to that in 2012?
Provide a short and direct response. 0. What is the ratio of the Total subscribers (per 100 people) in Liechtenstein in 2004 to that in 2012?
Offer a terse response. 0.35. What is the ratio of the Total subscribers (per 100 people) of Senegal in 2004 to that in 2012?
Provide a succinct answer. 0.1. What is the ratio of the Total subscribers (per 100 people) of Kazakhstan in 2004 to that in 2013?
Keep it short and to the point. 0. What is the ratio of the Total subscribers (per 100 people) of Liechtenstein in 2004 to that in 2013?
Offer a terse response. 0.34. What is the ratio of the Total subscribers (per 100 people) of Senegal in 2004 to that in 2013?
Offer a very short reply. 0.09. What is the ratio of the Total subscribers (per 100 people) of Liechtenstein in 2004 to that in 2014?
Give a very brief answer. 0.34. What is the ratio of the Total subscribers (per 100 people) of Senegal in 2004 to that in 2014?
Make the answer very short. 0.1. What is the ratio of the Total subscribers (per 100 people) of Kazakhstan in 2005 to that in 2006?
Keep it short and to the point. 0.1. What is the ratio of the Total subscribers (per 100 people) of Liechtenstein in 2005 to that in 2006?
Keep it short and to the point. 0.87. What is the ratio of the Total subscribers (per 100 people) in Senegal in 2005 to that in 2006?
Your answer should be very brief. 0.64. What is the ratio of the Total subscribers (per 100 people) of Kazakhstan in 2005 to that in 2007?
Provide a succinct answer. 0.01. What is the ratio of the Total subscribers (per 100 people) of Liechtenstein in 2005 to that in 2007?
Your answer should be very brief. 0.62. What is the ratio of the Total subscribers (per 100 people) in Senegal in 2005 to that in 2007?
Offer a very short reply. 0.5. What is the ratio of the Total subscribers (per 100 people) of Kazakhstan in 2005 to that in 2011?
Give a very brief answer. 0. What is the ratio of the Total subscribers (per 100 people) of Liechtenstein in 2005 to that in 2011?
Give a very brief answer. 0.66. What is the ratio of the Total subscribers (per 100 people) of Senegal in 2005 to that in 2011?
Your answer should be very brief. 0.23. What is the ratio of the Total subscribers (per 100 people) of Kazakhstan in 2005 to that in 2012?
Ensure brevity in your answer.  0. What is the ratio of the Total subscribers (per 100 people) of Liechtenstein in 2005 to that in 2012?
Keep it short and to the point. 0.63. What is the ratio of the Total subscribers (per 100 people) of Senegal in 2005 to that in 2012?
Keep it short and to the point. 0.23. What is the ratio of the Total subscribers (per 100 people) of Kazakhstan in 2005 to that in 2013?
Make the answer very short. 0. What is the ratio of the Total subscribers (per 100 people) in Liechtenstein in 2005 to that in 2013?
Keep it short and to the point. 0.61. What is the ratio of the Total subscribers (per 100 people) in Senegal in 2005 to that in 2013?
Your answer should be very brief. 0.21. What is the ratio of the Total subscribers (per 100 people) of Kazakhstan in 2005 to that in 2014?
Your answer should be very brief. 0. What is the ratio of the Total subscribers (per 100 people) of Liechtenstein in 2005 to that in 2014?
Keep it short and to the point. 0.61. What is the ratio of the Total subscribers (per 100 people) of Senegal in 2005 to that in 2014?
Your answer should be very brief. 0.23. What is the ratio of the Total subscribers (per 100 people) of Kazakhstan in 2006 to that in 2007?
Your answer should be very brief. 0.11. What is the ratio of the Total subscribers (per 100 people) of Liechtenstein in 2006 to that in 2007?
Your answer should be compact. 0.71. What is the ratio of the Total subscribers (per 100 people) of Senegal in 2006 to that in 2007?
Keep it short and to the point. 0.78. What is the ratio of the Total subscribers (per 100 people) in Kazakhstan in 2006 to that in 2011?
Offer a terse response. 0.03. What is the ratio of the Total subscribers (per 100 people) of Liechtenstein in 2006 to that in 2011?
Your answer should be compact. 0.76. What is the ratio of the Total subscribers (per 100 people) in Senegal in 2006 to that in 2011?
Keep it short and to the point. 0.36. What is the ratio of the Total subscribers (per 100 people) of Kazakhstan in 2006 to that in 2012?
Provide a succinct answer. 0.02. What is the ratio of the Total subscribers (per 100 people) of Liechtenstein in 2006 to that in 2012?
Offer a very short reply. 0.73. What is the ratio of the Total subscribers (per 100 people) of Senegal in 2006 to that in 2012?
Ensure brevity in your answer.  0.36. What is the ratio of the Total subscribers (per 100 people) in Kazakhstan in 2006 to that in 2013?
Offer a very short reply. 0.02. What is the ratio of the Total subscribers (per 100 people) in Liechtenstein in 2006 to that in 2013?
Your response must be concise. 0.7. What is the ratio of the Total subscribers (per 100 people) of Senegal in 2006 to that in 2013?
Offer a terse response. 0.33. What is the ratio of the Total subscribers (per 100 people) in Kazakhstan in 2006 to that in 2014?
Ensure brevity in your answer.  0.02. What is the ratio of the Total subscribers (per 100 people) of Liechtenstein in 2006 to that in 2014?
Provide a short and direct response. 0.71. What is the ratio of the Total subscribers (per 100 people) in Senegal in 2006 to that in 2014?
Your answer should be compact. 0.35. What is the ratio of the Total subscribers (per 100 people) of Kazakhstan in 2007 to that in 2011?
Offer a very short reply. 0.24. What is the ratio of the Total subscribers (per 100 people) in Liechtenstein in 2007 to that in 2011?
Give a very brief answer. 1.08. What is the ratio of the Total subscribers (per 100 people) of Senegal in 2007 to that in 2011?
Your answer should be very brief. 0.46. What is the ratio of the Total subscribers (per 100 people) in Kazakhstan in 2007 to that in 2012?
Make the answer very short. 0.17. What is the ratio of the Total subscribers (per 100 people) in Liechtenstein in 2007 to that in 2012?
Ensure brevity in your answer.  1.02. What is the ratio of the Total subscribers (per 100 people) of Senegal in 2007 to that in 2012?
Give a very brief answer. 0.46. What is the ratio of the Total subscribers (per 100 people) in Kazakhstan in 2007 to that in 2013?
Provide a short and direct response. 0.15. What is the ratio of the Total subscribers (per 100 people) of Senegal in 2007 to that in 2013?
Provide a succinct answer. 0.42. What is the ratio of the Total subscribers (per 100 people) of Kazakhstan in 2007 to that in 2014?
Offer a terse response. 0.14. What is the ratio of the Total subscribers (per 100 people) in Senegal in 2007 to that in 2014?
Keep it short and to the point. 0.45. What is the ratio of the Total subscribers (per 100 people) in Kazakhstan in 2011 to that in 2012?
Offer a terse response. 0.74. What is the ratio of the Total subscribers (per 100 people) of Liechtenstein in 2011 to that in 2012?
Your response must be concise. 0.95. What is the ratio of the Total subscribers (per 100 people) of Senegal in 2011 to that in 2012?
Give a very brief answer. 1. What is the ratio of the Total subscribers (per 100 people) in Kazakhstan in 2011 to that in 2013?
Your answer should be very brief. 0.62. What is the ratio of the Total subscribers (per 100 people) of Liechtenstein in 2011 to that in 2013?
Your response must be concise. 0.92. What is the ratio of the Total subscribers (per 100 people) in Senegal in 2011 to that in 2013?
Keep it short and to the point. 0.92. What is the ratio of the Total subscribers (per 100 people) of Kazakhstan in 2011 to that in 2014?
Offer a very short reply. 0.57. What is the ratio of the Total subscribers (per 100 people) of Liechtenstein in 2011 to that in 2014?
Provide a succinct answer. 0.93. What is the ratio of the Total subscribers (per 100 people) of Senegal in 2011 to that in 2014?
Provide a succinct answer. 0.98. What is the ratio of the Total subscribers (per 100 people) in Kazakhstan in 2012 to that in 2013?
Offer a terse response. 0.84. What is the ratio of the Total subscribers (per 100 people) in Liechtenstein in 2012 to that in 2013?
Your answer should be compact. 0.97. What is the ratio of the Total subscribers (per 100 people) in Senegal in 2012 to that in 2013?
Your answer should be compact. 0.92. What is the ratio of the Total subscribers (per 100 people) in Kazakhstan in 2012 to that in 2014?
Your response must be concise. 0.78. What is the ratio of the Total subscribers (per 100 people) of Liechtenstein in 2012 to that in 2014?
Make the answer very short. 0.98. What is the ratio of the Total subscribers (per 100 people) in Senegal in 2012 to that in 2014?
Offer a very short reply. 0.98. What is the ratio of the Total subscribers (per 100 people) of Kazakhstan in 2013 to that in 2014?
Give a very brief answer. 0.92. What is the ratio of the Total subscribers (per 100 people) in Liechtenstein in 2013 to that in 2014?
Your answer should be very brief. 1.01. What is the ratio of the Total subscribers (per 100 people) of Senegal in 2013 to that in 2014?
Give a very brief answer. 1.06. What is the difference between the highest and the second highest Total subscribers (per 100 people) of Kazakhstan?
Keep it short and to the point. 1.02. What is the difference between the highest and the second highest Total subscribers (per 100 people) in Liechtenstein?
Provide a succinct answer. 0.34. What is the difference between the highest and the second highest Total subscribers (per 100 people) of Senegal?
Provide a succinct answer. 0.04. What is the difference between the highest and the lowest Total subscribers (per 100 people) in Kazakhstan?
Make the answer very short. 12.92. What is the difference between the highest and the lowest Total subscribers (per 100 people) of Liechtenstein?
Ensure brevity in your answer.  26.9. What is the difference between the highest and the lowest Total subscribers (per 100 people) in Senegal?
Offer a very short reply. 0.69. 